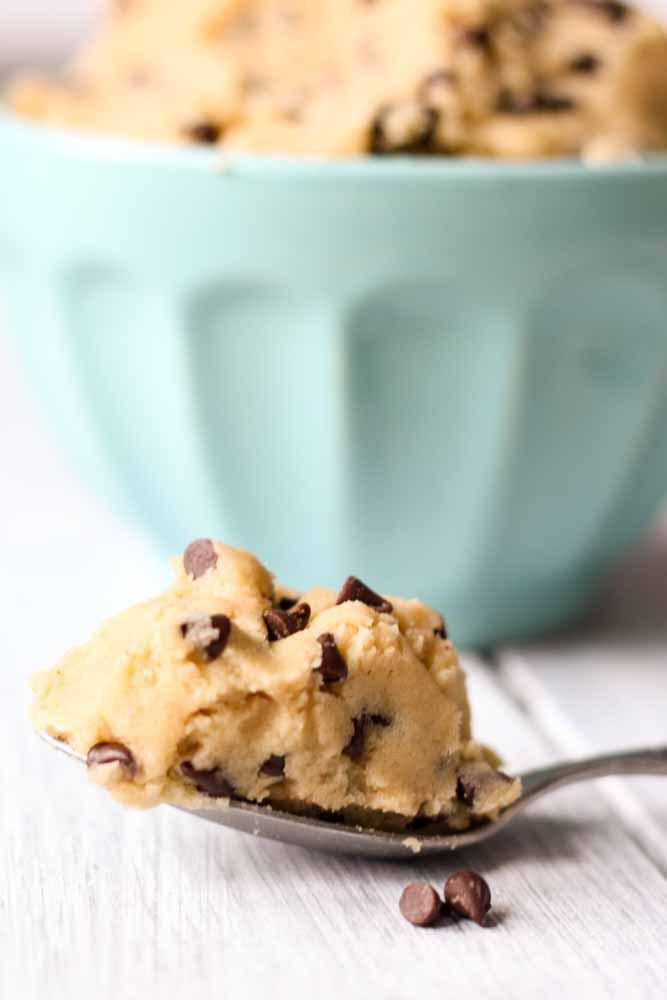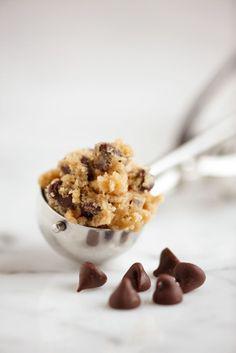The first image is the image on the left, the second image is the image on the right. For the images shown, is this caption "There is a spoon filled with cookie dough in the center of each image." true? Answer yes or no. Yes. The first image is the image on the left, the second image is the image on the right. Examine the images to the left and right. Is the description "There is at least one human hand holding a spoon." accurate? Answer yes or no. No. 